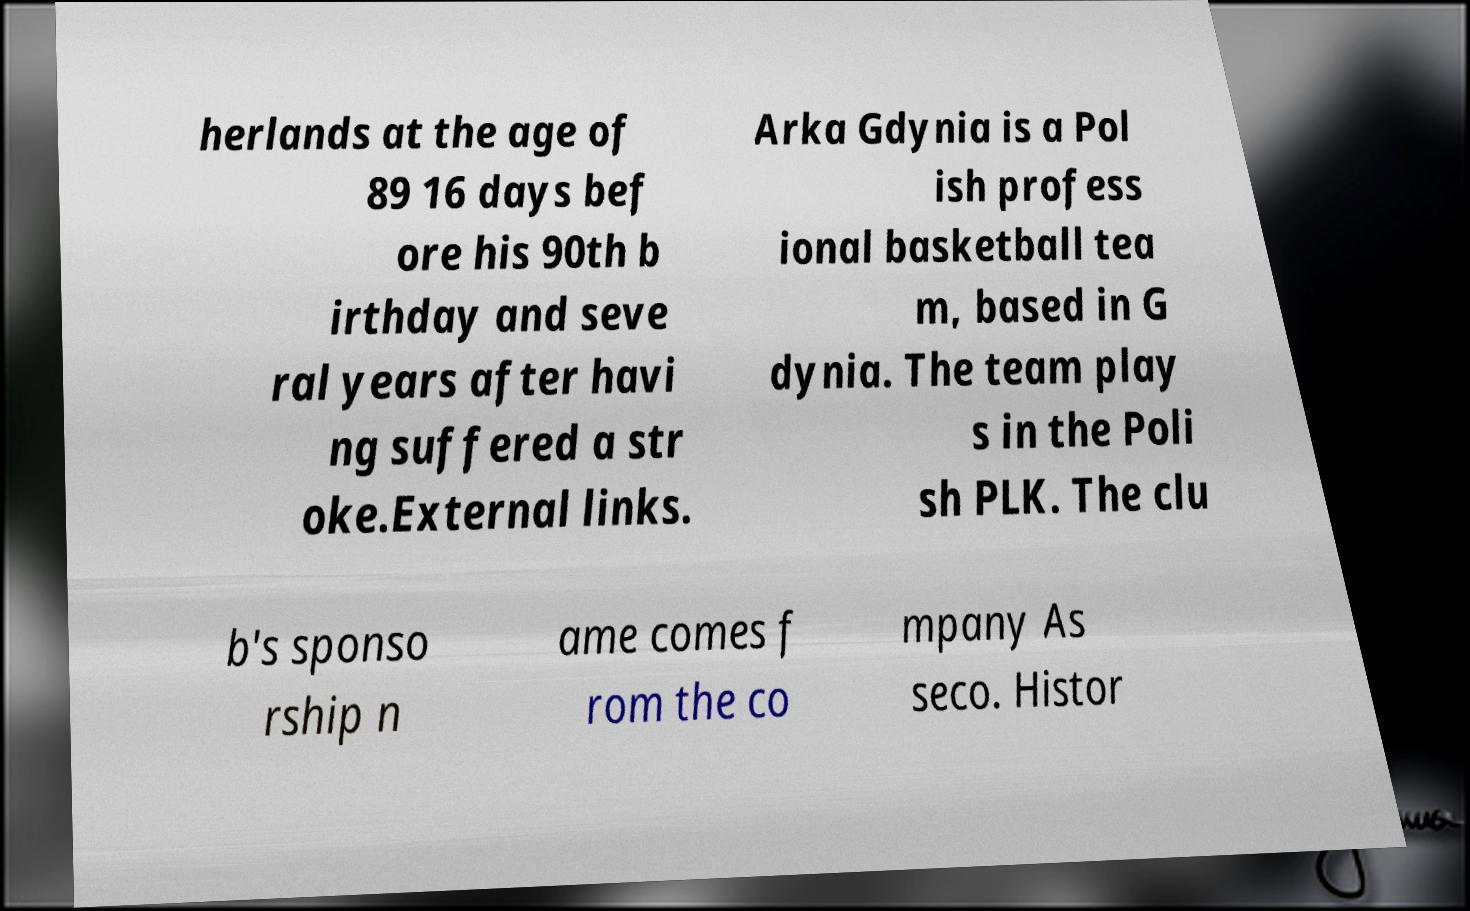Can you accurately transcribe the text from the provided image for me? herlands at the age of 89 16 days bef ore his 90th b irthday and seve ral years after havi ng suffered a str oke.External links. Arka Gdynia is a Pol ish profess ional basketball tea m, based in G dynia. The team play s in the Poli sh PLK. The clu b's sponso rship n ame comes f rom the co mpany As seco. Histor 